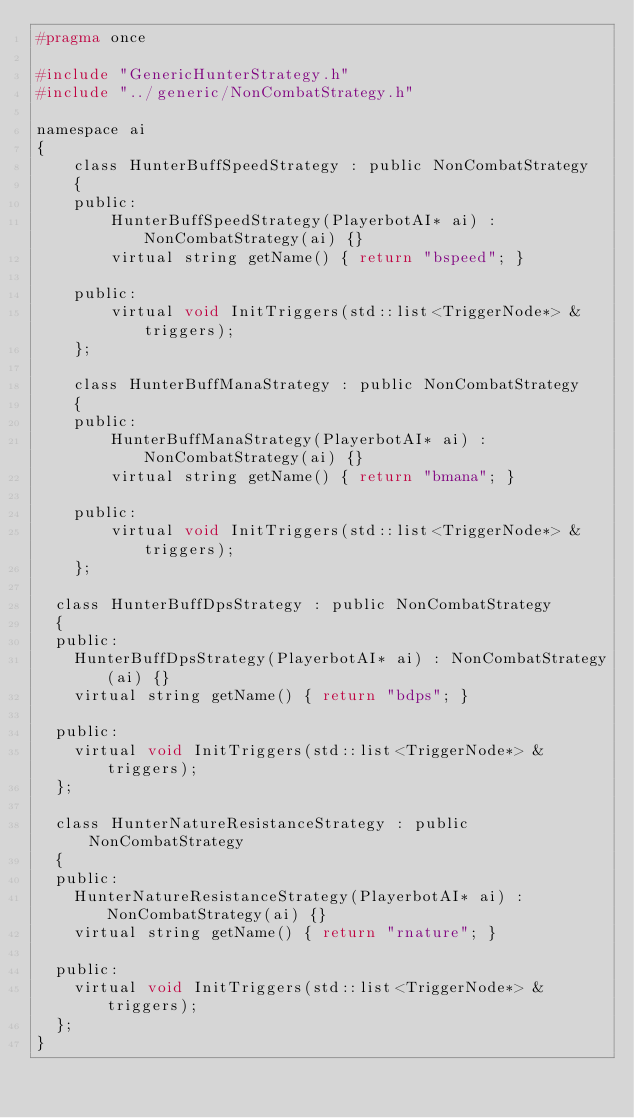Convert code to text. <code><loc_0><loc_0><loc_500><loc_500><_C_>#pragma once

#include "GenericHunterStrategy.h"
#include "../generic/NonCombatStrategy.h"

namespace ai
{
    class HunterBuffSpeedStrategy : public NonCombatStrategy
    {
    public:
        HunterBuffSpeedStrategy(PlayerbotAI* ai) : NonCombatStrategy(ai) {}
        virtual string getName() { return "bspeed"; }

    public:
        virtual void InitTriggers(std::list<TriggerNode*> &triggers);
    };

    class HunterBuffManaStrategy : public NonCombatStrategy
    {
    public:
        HunterBuffManaStrategy(PlayerbotAI* ai) : NonCombatStrategy(ai) {}
        virtual string getName() { return "bmana"; }

    public:
        virtual void InitTriggers(std::list<TriggerNode*> &triggers);
    };

	class HunterBuffDpsStrategy : public NonCombatStrategy
	{
	public:
		HunterBuffDpsStrategy(PlayerbotAI* ai) : NonCombatStrategy(ai) {}
		virtual string getName() { return "bdps"; }

	public:
		virtual void InitTriggers(std::list<TriggerNode*> &triggers);
	};

	class HunterNatureResistanceStrategy : public NonCombatStrategy
	{
	public:
		HunterNatureResistanceStrategy(PlayerbotAI* ai) : NonCombatStrategy(ai) {}
		virtual string getName() { return "rnature"; }

	public:
		virtual void InitTriggers(std::list<TriggerNode*> &triggers);
	};
}
</code> 